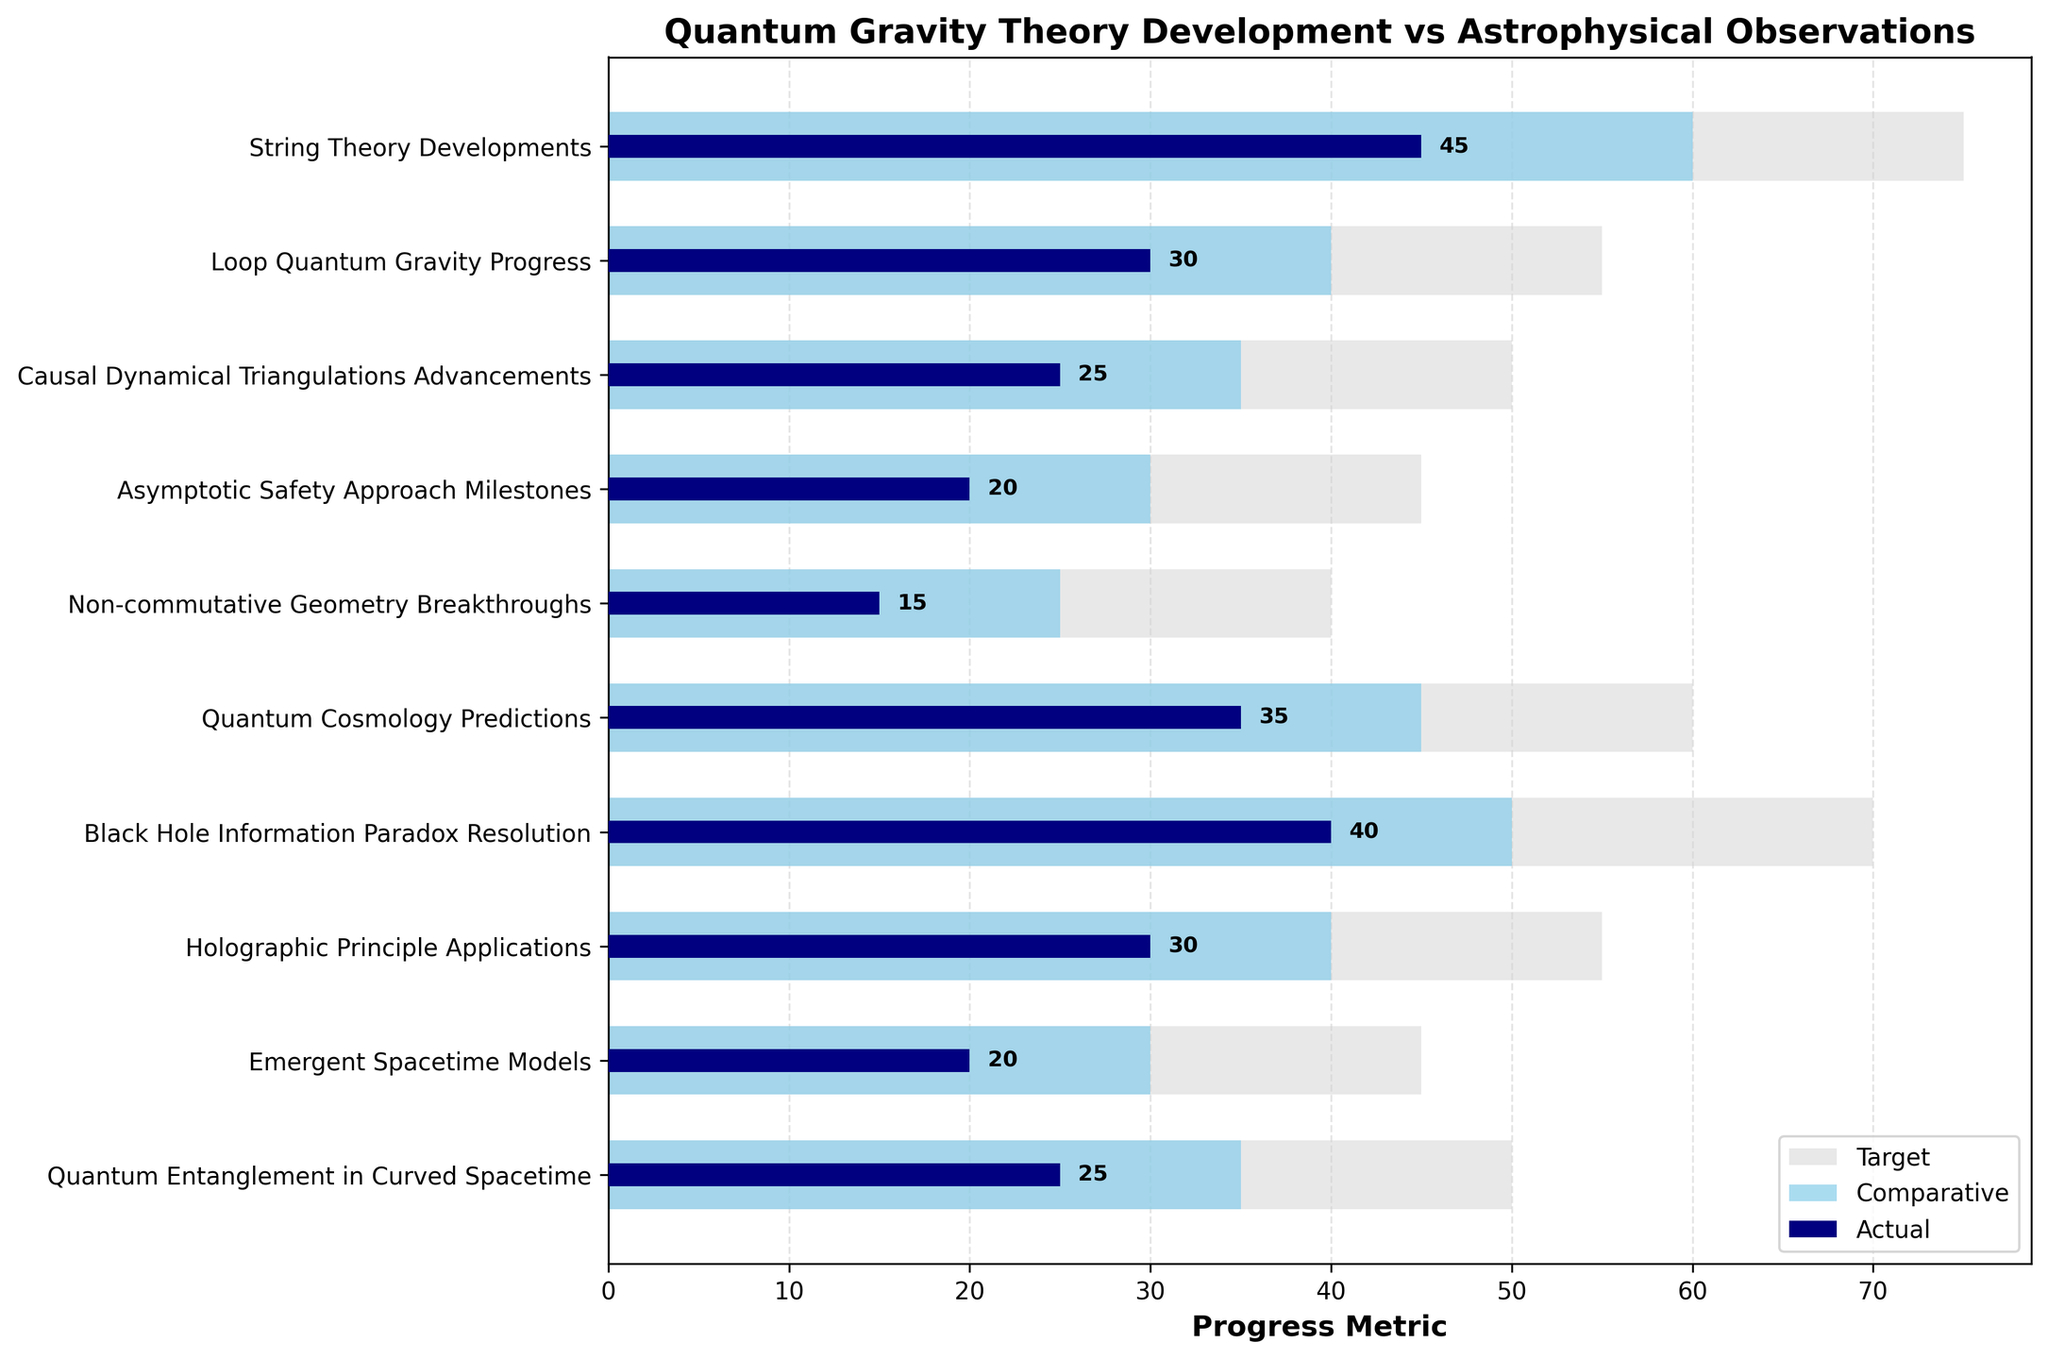What is the title of the figure? The title is prominently displayed at the top of the plot. It reads "Quantum Gravity Theory Development vs Astrophysical Observations."
Answer: Quantum Gravity Theory Development vs Astrophysical Observations How many development milestones are shown in the figure? The y-axis lists the number of development milestones. There are 10 items labeled from "String Theory Developments" to "Quantum Entanglement in Curved Spacetime."
Answer: 10 What is the actual progress metric for “String Theory Developments”? Locate "String Theory Developments" on the y-axis and check the thick line closest to it, representing the actual progress metric, which is labeled as 45.
Answer: 45 Which milestone has the lowest comparative metric? Look through the light blue bars, which represent the comparative metrics, and locate the smallest value. "Non-commutative Geometry Breakthroughs" has the lowest comparative metric at 25.
Answer: Non-commutative Geometry Breakthroughs What are the target and comparative metrics for “Black Hole Information Paradox Resolution”? Locate "Black Hole Information Paradox Resolution" on the y-axis and follow the bars to their endpoints. The target metric is 70 and the comparative metric is 50.
Answer: 70 (target) and 50 (comparative) How many milestones have an actual progress metric greater than 30? Count the milestones with a thick line representing actual metrics that exceed 30. "String Theory Developments", "Loop Quantum Gravity Progress", "Quantum Cosmology Predictions", "Black Hole Information Paradox Resolution", "Holographic Principle Applications" sum up to 5.
Answer: 5 Which milestones have both their comparative and target values equal? Compare the light blue and gray bars. None of the milestones have these values equal, as the bars representing comparative and target values for each milestone are distinct.
Answer: None What is the progress gap between the target and actual metrics for “Emergent Spacetime Models”? Calculate the difference between the target metric (45) and the actual metric (20) for "Emergent Spacetime Models": 45 - 20 = 25.
Answer: 25 Which milestone exhibits the smallest difference between its comparative and actual metrics? Find the differences for each milestone, then identify the smallest. "String Theory Developments" with a difference of 60 - 45 = 15 is the smallest.
Answer: String Theory Developments What is the average target metric of the milestones related to quantum realism? Identify and sum the target metrics for "Loop Quantum Gravity Progress", "Quantum Cosmology Predictions", and "Quantum Entanglement in Curved Spacetime" (55 + 60 + 50 = 165), then divide by 3 for the average: 165 / 3 = 55.
Answer: 55 